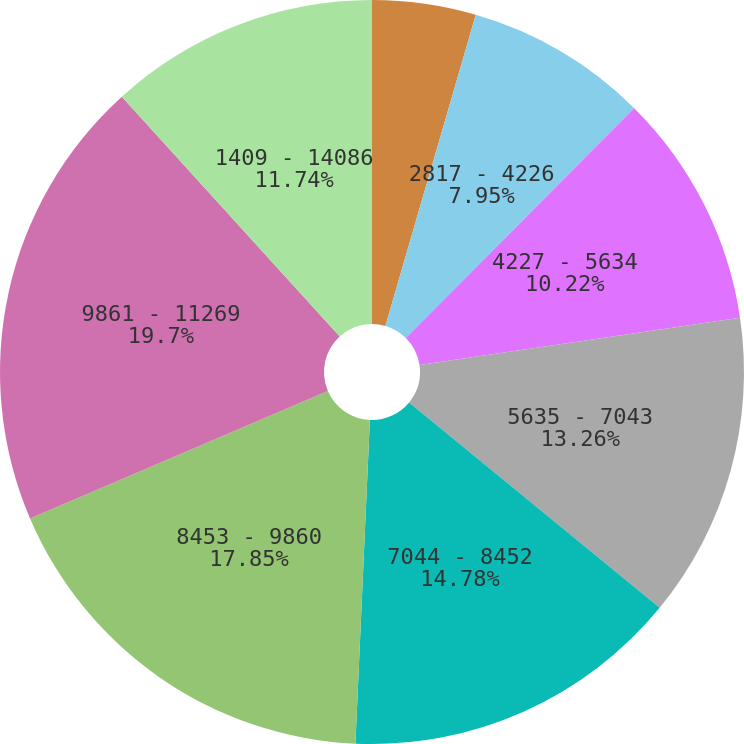Convert chart. <chart><loc_0><loc_0><loc_500><loc_500><pie_chart><fcel>1409 - 2817<fcel>2817 - 4226<fcel>4227 - 5634<fcel>5635 - 7043<fcel>7044 - 8452<fcel>8453 - 9860<fcel>9861 - 11269<fcel>1409 - 14086<nl><fcel>4.5%<fcel>7.95%<fcel>10.22%<fcel>13.26%<fcel>14.78%<fcel>17.85%<fcel>19.7%<fcel>11.74%<nl></chart> 